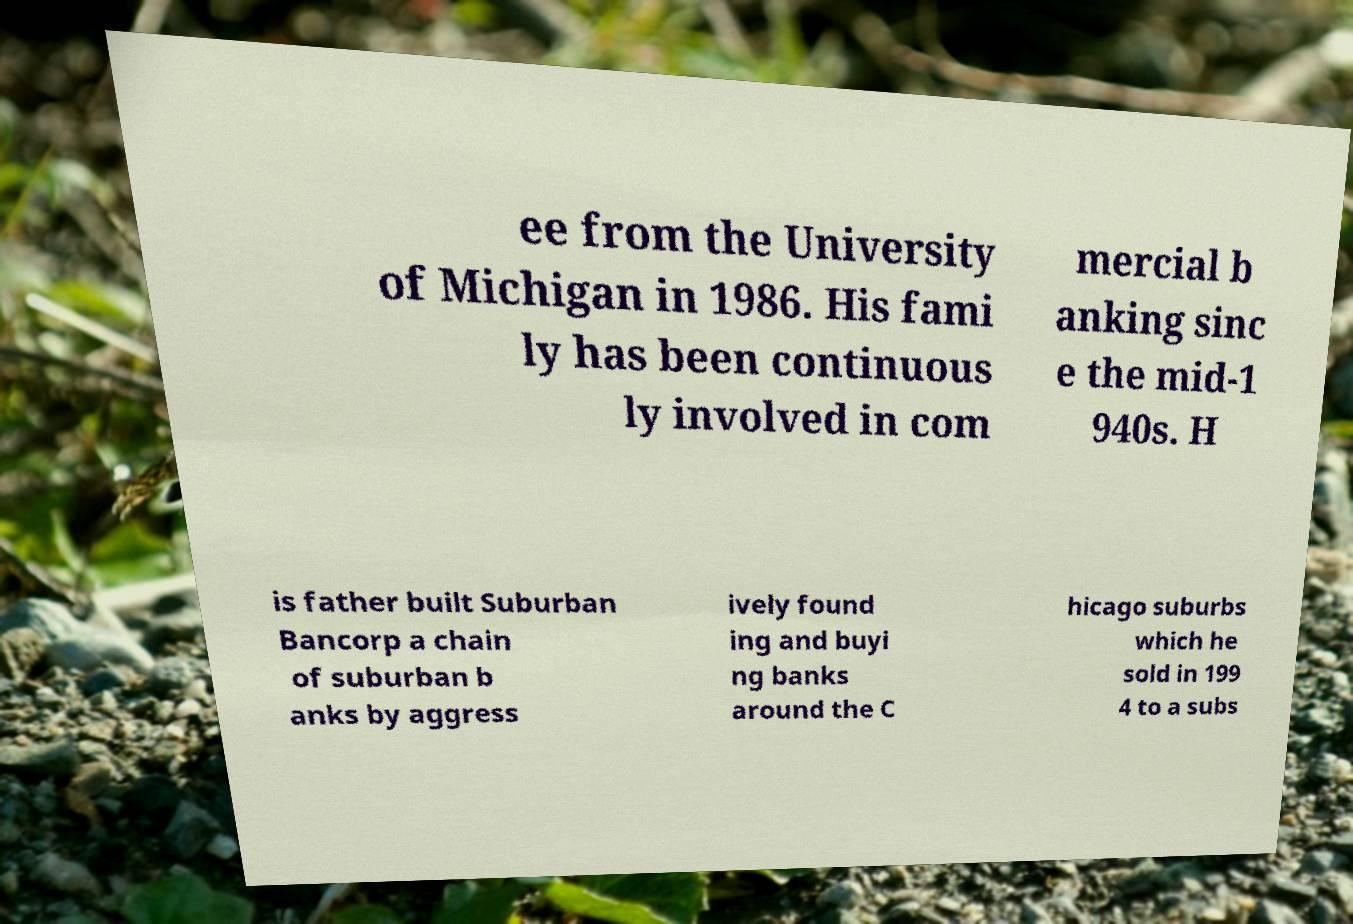There's text embedded in this image that I need extracted. Can you transcribe it verbatim? ee from the University of Michigan in 1986. His fami ly has been continuous ly involved in com mercial b anking sinc e the mid-1 940s. H is father built Suburban Bancorp a chain of suburban b anks by aggress ively found ing and buyi ng banks around the C hicago suburbs which he sold in 199 4 to a subs 